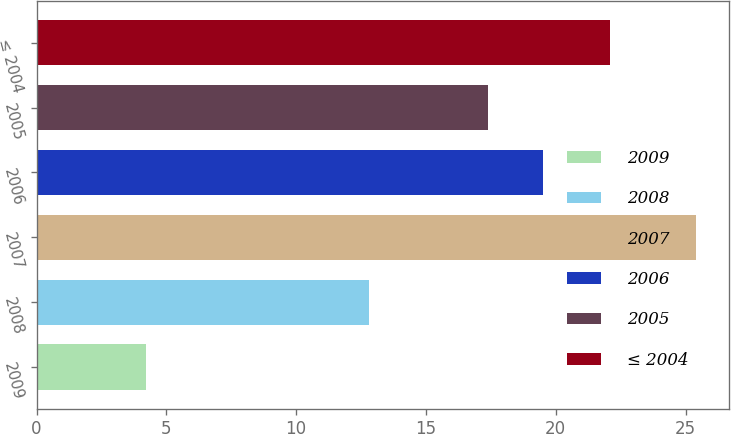<chart> <loc_0><loc_0><loc_500><loc_500><bar_chart><fcel>2009<fcel>2008<fcel>2007<fcel>2006<fcel>2005<fcel>≤ 2004<nl><fcel>4.2<fcel>12.8<fcel>25.4<fcel>19.52<fcel>17.4<fcel>22.1<nl></chart> 